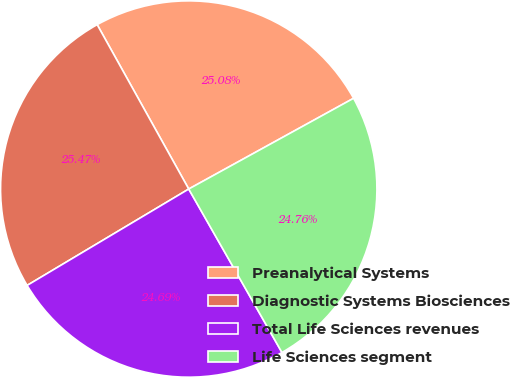Convert chart to OTSL. <chart><loc_0><loc_0><loc_500><loc_500><pie_chart><fcel>Preanalytical Systems<fcel>Diagnostic Systems Biosciences<fcel>Total Life Sciences revenues<fcel>Life Sciences segment<nl><fcel>25.08%<fcel>25.47%<fcel>24.69%<fcel>24.76%<nl></chart> 